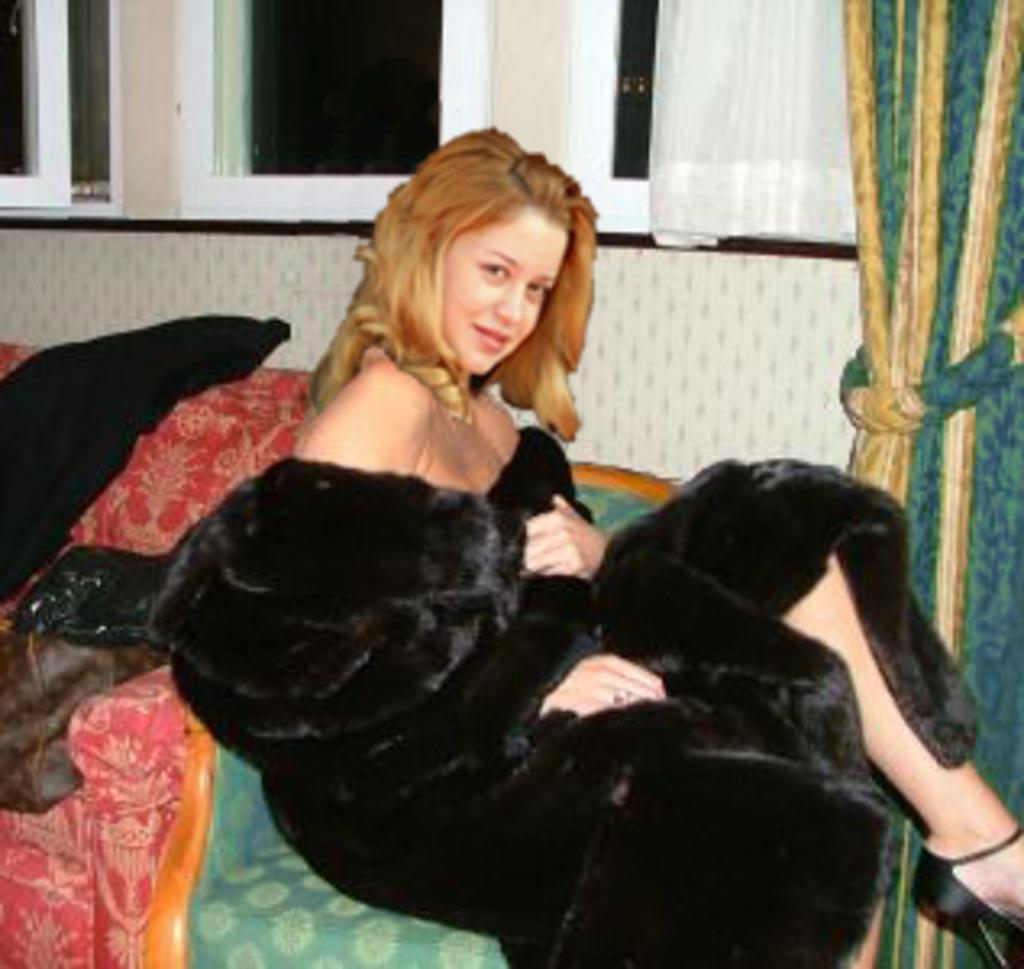Please provide a concise description of this image. In this image we can see a lady sitting on the couch, there are windows, curtains, also we can see the wall, and some clothes on the couch. 